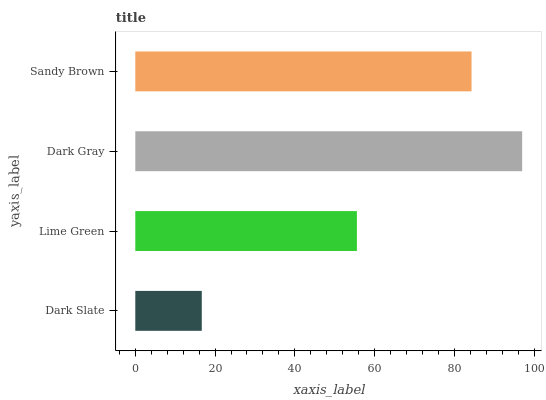Is Dark Slate the minimum?
Answer yes or no. Yes. Is Dark Gray the maximum?
Answer yes or no. Yes. Is Lime Green the minimum?
Answer yes or no. No. Is Lime Green the maximum?
Answer yes or no. No. Is Lime Green greater than Dark Slate?
Answer yes or no. Yes. Is Dark Slate less than Lime Green?
Answer yes or no. Yes. Is Dark Slate greater than Lime Green?
Answer yes or no. No. Is Lime Green less than Dark Slate?
Answer yes or no. No. Is Sandy Brown the high median?
Answer yes or no. Yes. Is Lime Green the low median?
Answer yes or no. Yes. Is Lime Green the high median?
Answer yes or no. No. Is Sandy Brown the low median?
Answer yes or no. No. 